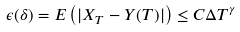Convert formula to latex. <formula><loc_0><loc_0><loc_500><loc_500>\epsilon ( \delta ) = E \left ( | X _ { T } - Y ( T ) | \right ) \leq C \Delta T ^ { \gamma }</formula> 